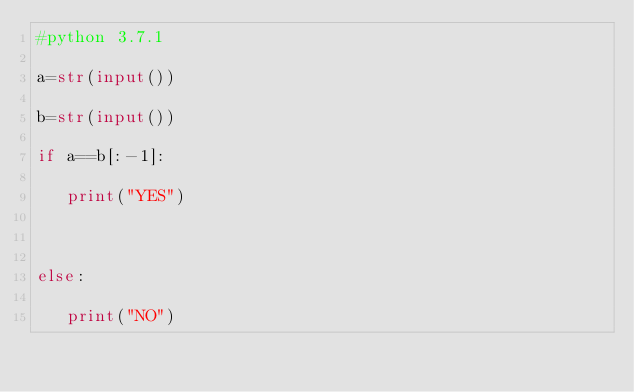<code> <loc_0><loc_0><loc_500><loc_500><_Python_>#python 3.7.1

a=str(input())

b=str(input())

if a==b[:-1]:

   print("YES")

    

else:

   print("NO")

</code> 